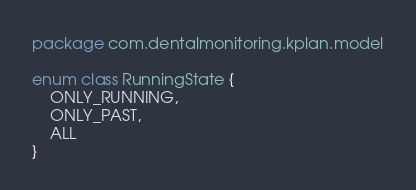<code> <loc_0><loc_0><loc_500><loc_500><_Kotlin_>package com.dentalmonitoring.kplan.model

enum class RunningState {
    ONLY_RUNNING,
    ONLY_PAST,
    ALL
}</code> 